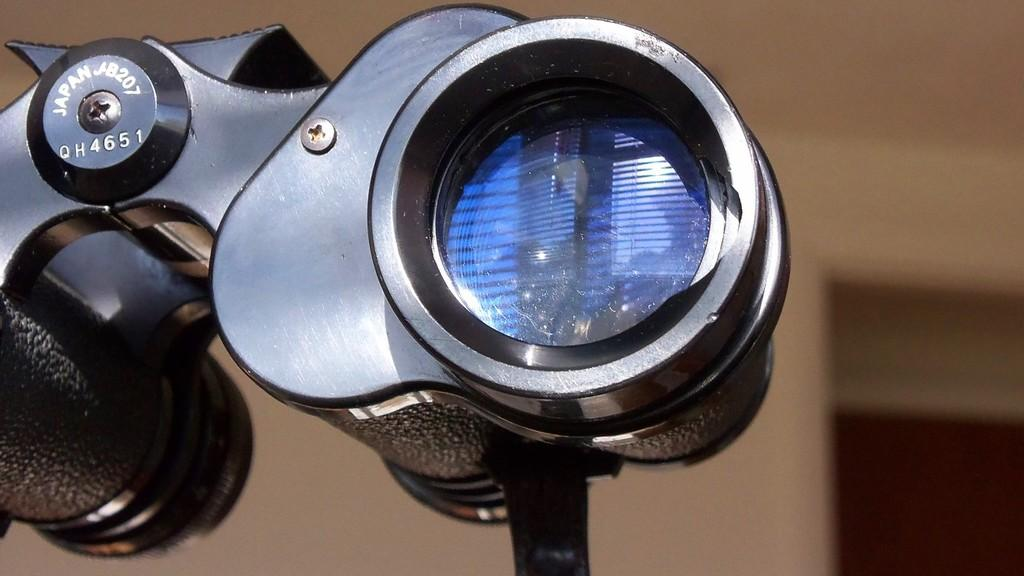What is the color of the main object in the image? The main object in the image is black colored. What does the main object in the image resemble? The main object resembles a binocular. How would you describe the background of the image? The background of the image is blurry. What is the color of the background in the image? The background color is brown. Can you see any children playing on a playground in the image? There is no playground or children present in the image. What type of egg is visible in the image? There are no eggs present in the image. 